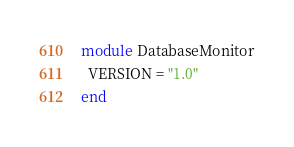Convert code to text. <code><loc_0><loc_0><loc_500><loc_500><_Ruby_>module DatabaseMonitor
  VERSION = "1.0"
end
</code> 